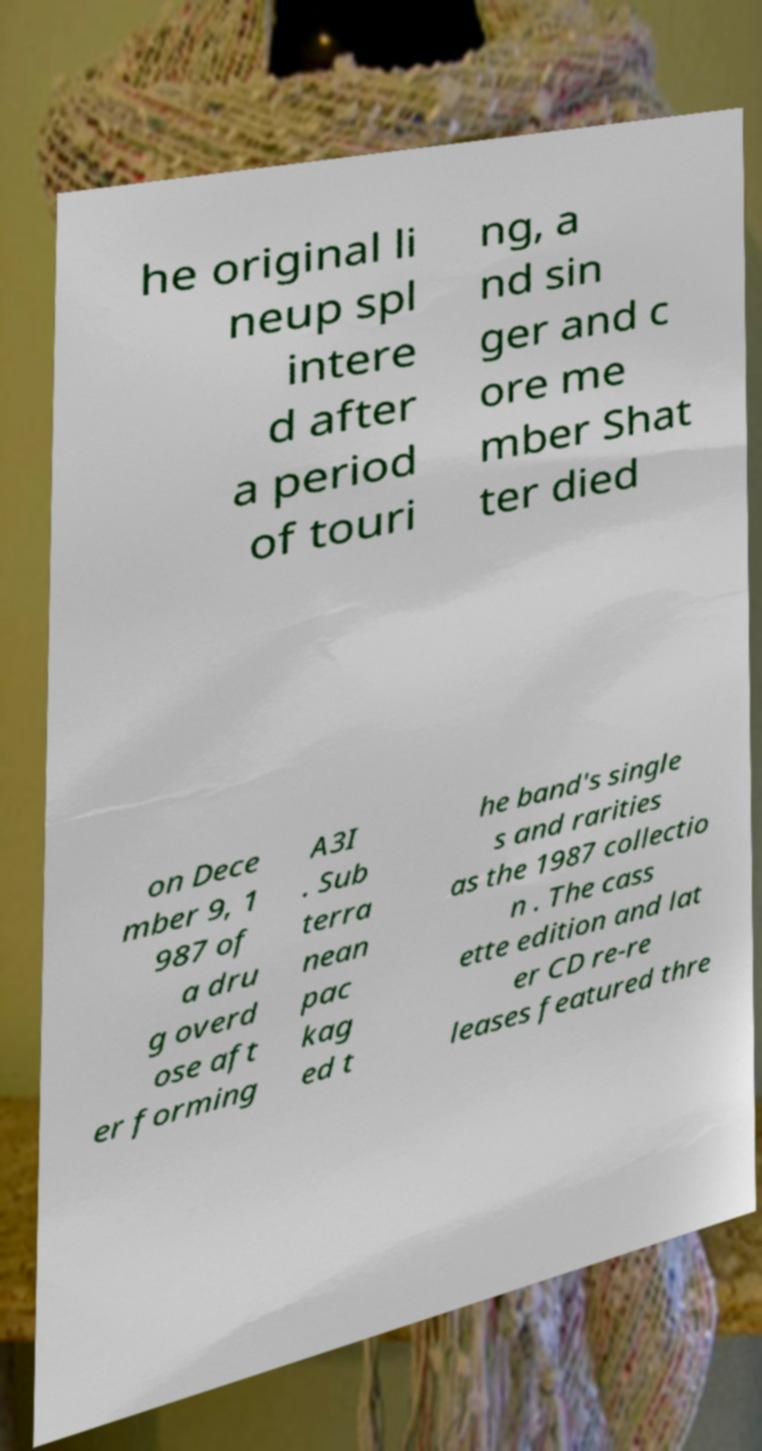Can you accurately transcribe the text from the provided image for me? he original li neup spl intere d after a period of touri ng, a nd sin ger and c ore me mber Shat ter died on Dece mber 9, 1 987 of a dru g overd ose aft er forming A3I . Sub terra nean pac kag ed t he band's single s and rarities as the 1987 collectio n . The cass ette edition and lat er CD re-re leases featured thre 